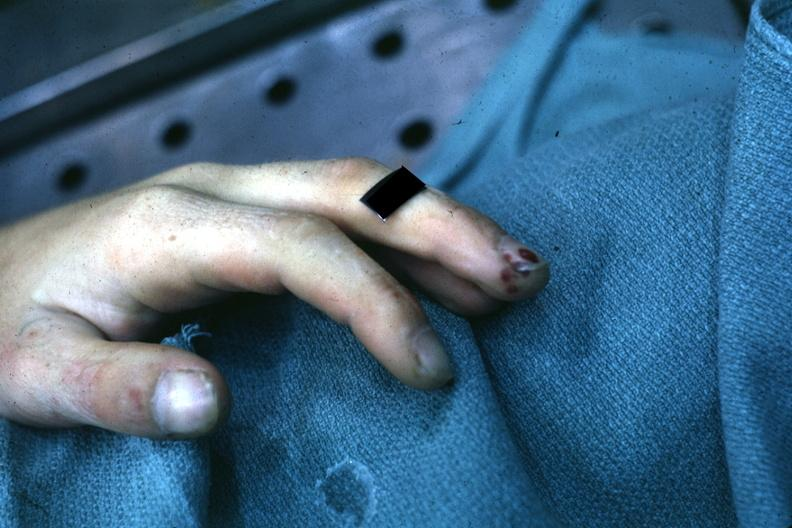how is very good example of focal necrotizing lesions in distal portion of digit associated with endocarditis?
Answer the question using a single word or phrase. Bacterial 